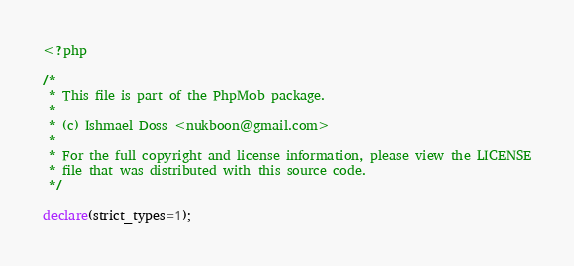Convert code to text. <code><loc_0><loc_0><loc_500><loc_500><_PHP_><?php

/*
 * This file is part of the PhpMob package.
 *
 * (c) Ishmael Doss <nukboon@gmail.com>
 *
 * For the full copyright and license information, please view the LICENSE
 * file that was distributed with this source code.
 */

declare(strict_types=1);
</code> 